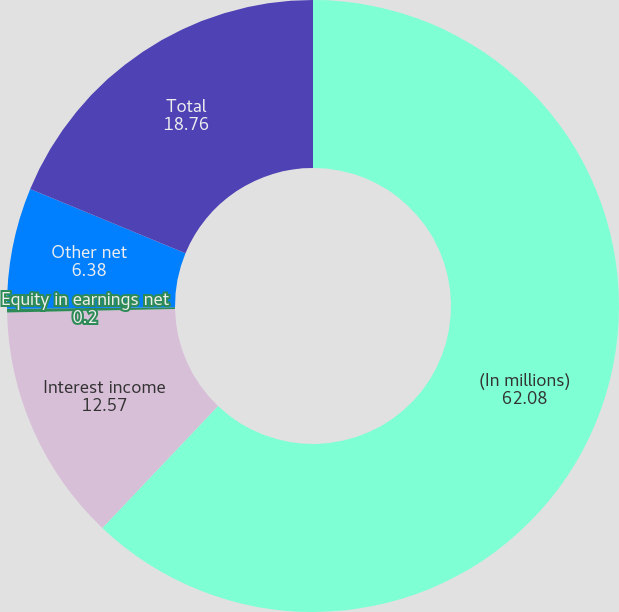<chart> <loc_0><loc_0><loc_500><loc_500><pie_chart><fcel>(In millions)<fcel>Interest income<fcel>Equity in earnings net<fcel>Other net<fcel>Total<nl><fcel>62.08%<fcel>12.57%<fcel>0.2%<fcel>6.38%<fcel>18.76%<nl></chart> 